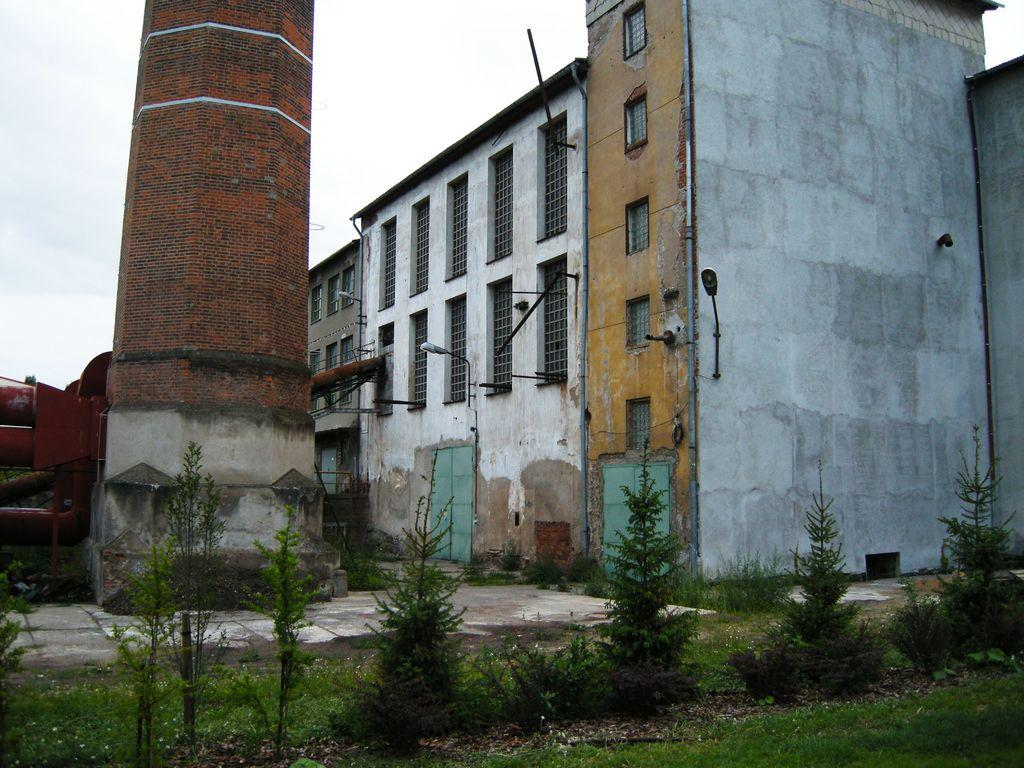What type of structures can be seen in the image? There are buildings in the image. What can be seen illuminated in the image? There are lights visible in the image. What type of vegetation is present in the image? There are plants and grass in the image. What architectural features can be seen in the image? There are windows and a tower in the image. What other objects can be seen in the image? There are poles in the image. What is visible in the background of the image? The sky is visible in the background of the image. What type of garden can be seen in the image? There is no garden present in the image. What trick is being performed in the image? There is no trick being performed in the image. 